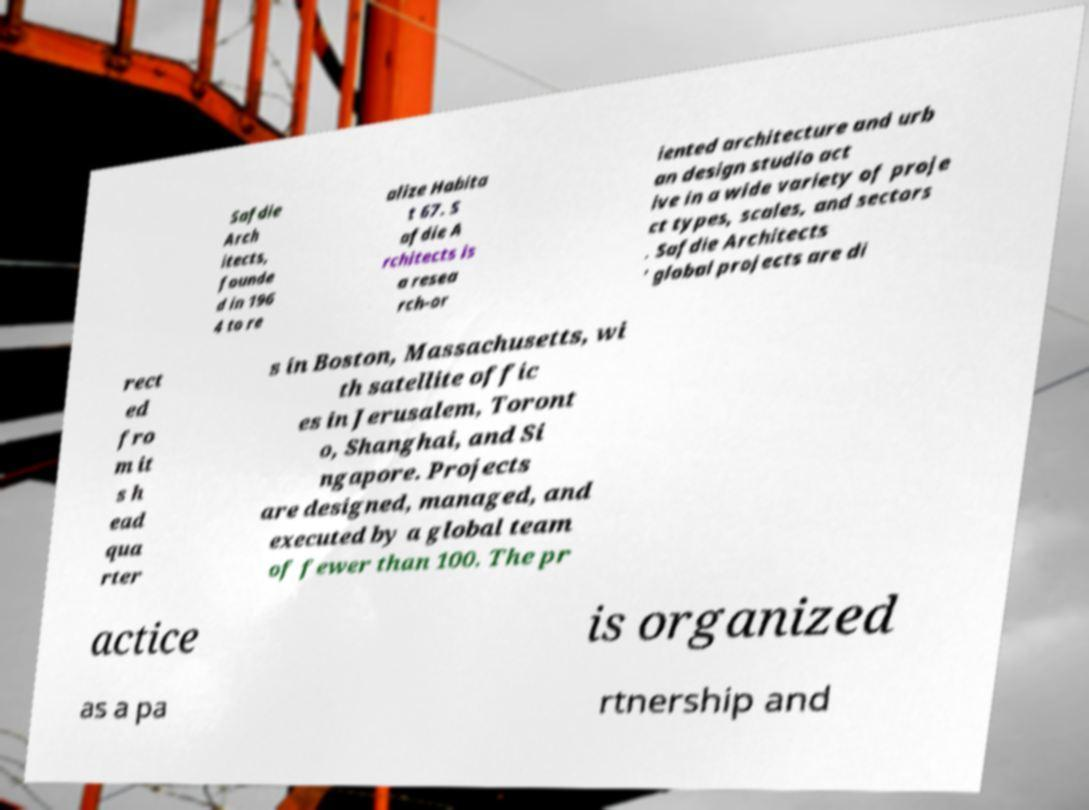Can you read and provide the text displayed in the image?This photo seems to have some interesting text. Can you extract and type it out for me? Safdie Arch itects, founde d in 196 4 to re alize Habita t 67. S afdie A rchitects is a resea rch-or iented architecture and urb an design studio act ive in a wide variety of proje ct types, scales, and sectors . Safdie Architects ’ global projects are di rect ed fro m it s h ead qua rter s in Boston, Massachusetts, wi th satellite offic es in Jerusalem, Toront o, Shanghai, and Si ngapore. Projects are designed, managed, and executed by a global team of fewer than 100. The pr actice is organized as a pa rtnership and 